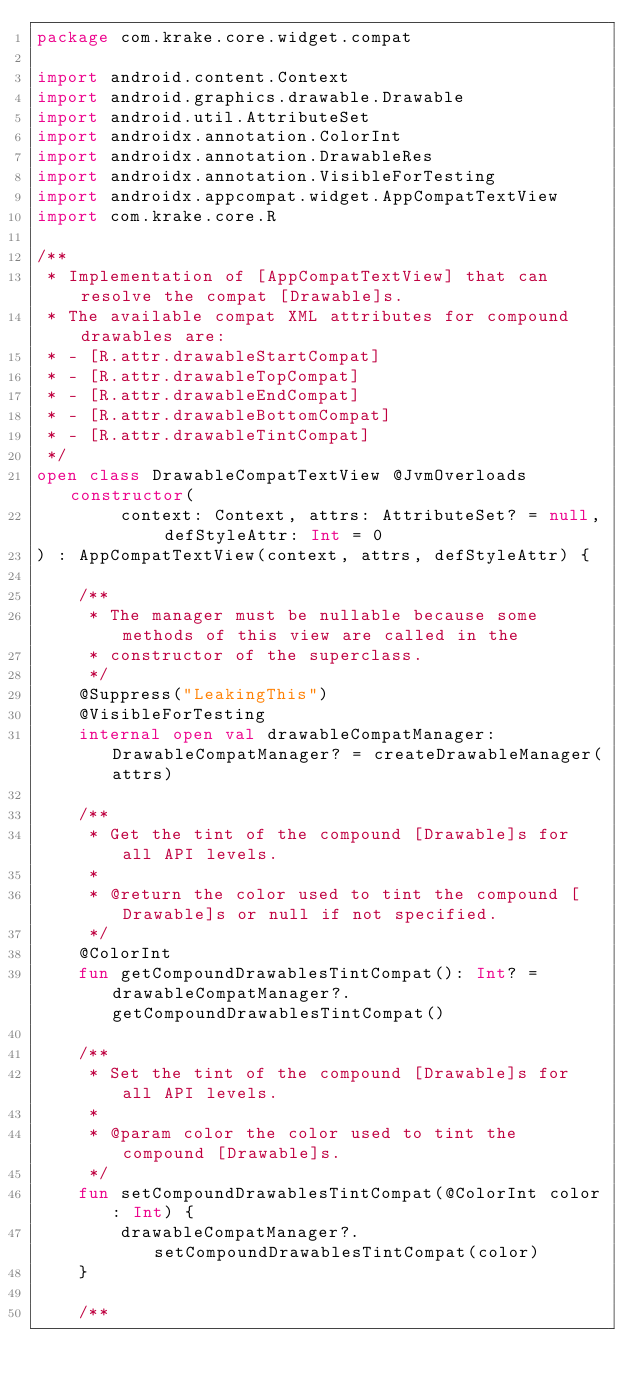Convert code to text. <code><loc_0><loc_0><loc_500><loc_500><_Kotlin_>package com.krake.core.widget.compat

import android.content.Context
import android.graphics.drawable.Drawable
import android.util.AttributeSet
import androidx.annotation.ColorInt
import androidx.annotation.DrawableRes
import androidx.annotation.VisibleForTesting
import androidx.appcompat.widget.AppCompatTextView
import com.krake.core.R

/**
 * Implementation of [AppCompatTextView] that can resolve the compat [Drawable]s.
 * The available compat XML attributes for compound drawables are:
 * - [R.attr.drawableStartCompat]
 * - [R.attr.drawableTopCompat]
 * - [R.attr.drawableEndCompat]
 * - [R.attr.drawableBottomCompat]
 * - [R.attr.drawableTintCompat]
 */
open class DrawableCompatTextView @JvmOverloads constructor(
        context: Context, attrs: AttributeSet? = null, defStyleAttr: Int = 0
) : AppCompatTextView(context, attrs, defStyleAttr) {

    /**
     * The manager must be nullable because some methods of this view are called in the
     * constructor of the superclass.
     */
    @Suppress("LeakingThis")
    @VisibleForTesting
    internal open val drawableCompatManager: DrawableCompatManager? = createDrawableManager(attrs)

    /**
     * Get the tint of the compound [Drawable]s for all API levels.
     *
     * @return the color used to tint the compound [Drawable]s or null if not specified.
     */
    @ColorInt
    fun getCompoundDrawablesTintCompat(): Int? = drawableCompatManager?.getCompoundDrawablesTintCompat()

    /**
     * Set the tint of the compound [Drawable]s for all API levels.
     *
     * @param color the color used to tint the compound [Drawable]s.
     */
    fun setCompoundDrawablesTintCompat(@ColorInt color: Int) {
        drawableCompatManager?.setCompoundDrawablesTintCompat(color)
    }

    /**</code> 